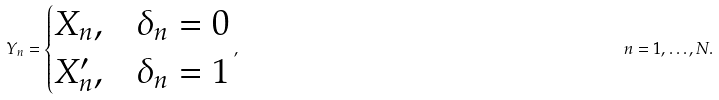<formula> <loc_0><loc_0><loc_500><loc_500>Y _ { n } = \begin{cases} X _ { n } , & \delta _ { n } = 0 \\ X ^ { \prime } _ { n } , & \delta _ { n } = 1 \\ \end{cases} , & & n = 1 , \dots , N .</formula> 